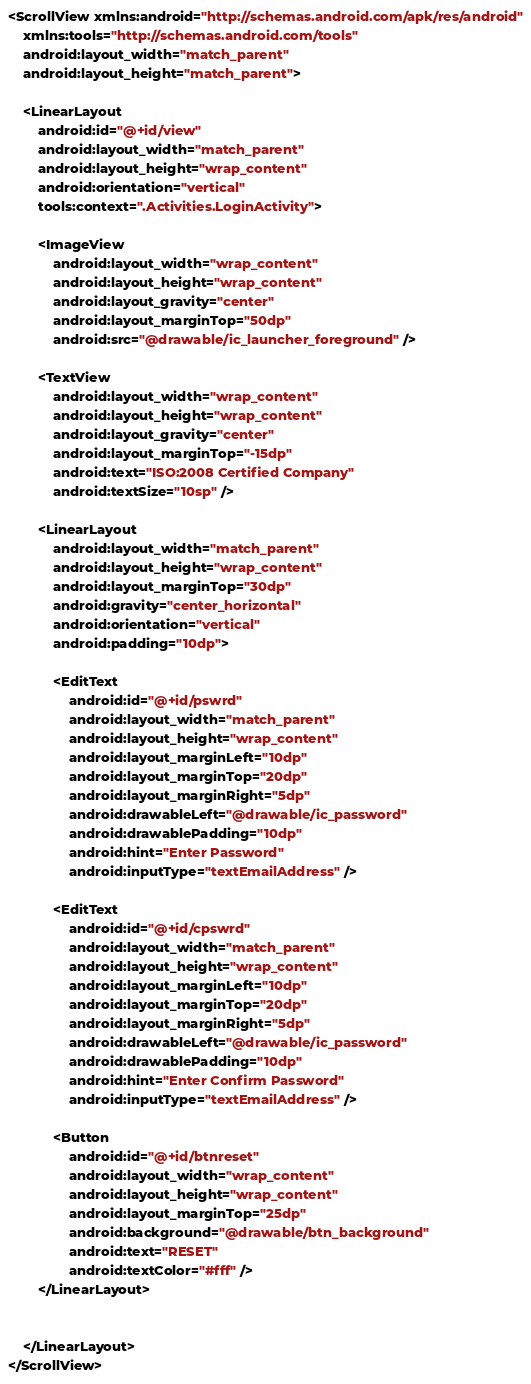<code> <loc_0><loc_0><loc_500><loc_500><_XML_><ScrollView xmlns:android="http://schemas.android.com/apk/res/android"
    xmlns:tools="http://schemas.android.com/tools"
    android:layout_width="match_parent"
    android:layout_height="match_parent">

    <LinearLayout
        android:id="@+id/view"
        android:layout_width="match_parent"
        android:layout_height="wrap_content"
        android:orientation="vertical"
        tools:context=".Activities.LoginActivity">

        <ImageView
            android:layout_width="wrap_content"
            android:layout_height="wrap_content"
            android:layout_gravity="center"
            android:layout_marginTop="50dp"
            android:src="@drawable/ic_launcher_foreground" />

        <TextView
            android:layout_width="wrap_content"
            android:layout_height="wrap_content"
            android:layout_gravity="center"
            android:layout_marginTop="-15dp"
            android:text="ISO:2008 Certified Company"
            android:textSize="10sp" />

        <LinearLayout
            android:layout_width="match_parent"
            android:layout_height="wrap_content"
            android:layout_marginTop="30dp"
            android:gravity="center_horizontal"
            android:orientation="vertical"
            android:padding="10dp">

            <EditText
                android:id="@+id/pswrd"
                android:layout_width="match_parent"
                android:layout_height="wrap_content"
                android:layout_marginLeft="10dp"
                android:layout_marginTop="20dp"
                android:layout_marginRight="5dp"
                android:drawableLeft="@drawable/ic_password"
                android:drawablePadding="10dp"
                android:hint="Enter Password"
                android:inputType="textEmailAddress" />

            <EditText
                android:id="@+id/cpswrd"
                android:layout_width="match_parent"
                android:layout_height="wrap_content"
                android:layout_marginLeft="10dp"
                android:layout_marginTop="20dp"
                android:layout_marginRight="5dp"
                android:drawableLeft="@drawable/ic_password"
                android:drawablePadding="10dp"
                android:hint="Enter Confirm Password"
                android:inputType="textEmailAddress" />

            <Button
                android:id="@+id/btnreset"
                android:layout_width="wrap_content"
                android:layout_height="wrap_content"
                android:layout_marginTop="25dp"
                android:background="@drawable/btn_background"
                android:text="RESET"
                android:textColor="#fff" />
        </LinearLayout>


    </LinearLayout>
</ScrollView></code> 